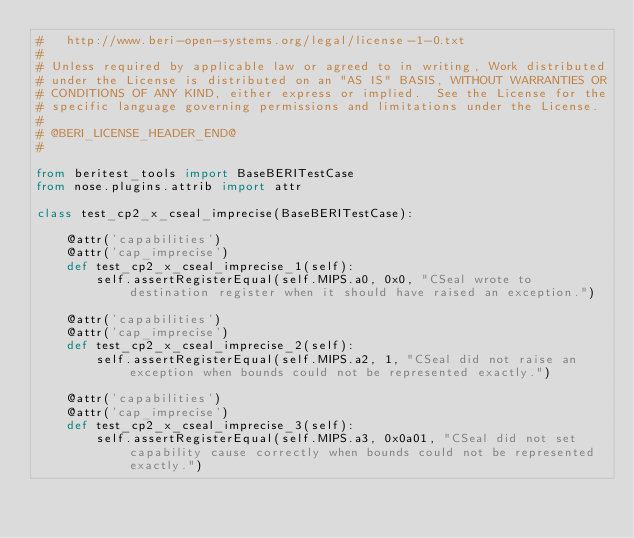Convert code to text. <code><loc_0><loc_0><loc_500><loc_500><_Python_>#   http://www.beri-open-systems.org/legal/license-1-0.txt
#
# Unless required by applicable law or agreed to in writing, Work distributed
# under the License is distributed on an "AS IS" BASIS, WITHOUT WARRANTIES OR
# CONDITIONS OF ANY KIND, either express or implied.  See the License for the
# specific language governing permissions and limitations under the License.
#
# @BERI_LICENSE_HEADER_END@
#

from beritest_tools import BaseBERITestCase
from nose.plugins.attrib import attr

class test_cp2_x_cseal_imprecise(BaseBERITestCase):

    @attr('capabilities')
    @attr('cap_imprecise')
    def test_cp2_x_cseal_imprecise_1(self):
        self.assertRegisterEqual(self.MIPS.a0, 0x0, "CSeal wrote to destination register when it should have raised an exception.")

    @attr('capabilities')
    @attr('cap_imprecise')
    def test_cp2_x_cseal_imprecise_2(self):
        self.assertRegisterEqual(self.MIPS.a2, 1, "CSeal did not raise an exception when bounds could not be represented exactly.")

    @attr('capabilities')
    @attr('cap_imprecise')
    def test_cp2_x_cseal_imprecise_3(self):
        self.assertRegisterEqual(self.MIPS.a3, 0x0a01, "CSeal did not set capability cause correctly when bounds could not be represented exactly.")

</code> 